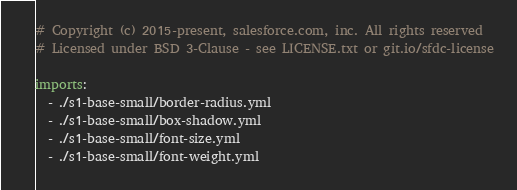<code> <loc_0><loc_0><loc_500><loc_500><_YAML_># Copyright (c) 2015-present, salesforce.com, inc. All rights reserved
# Licensed under BSD 3-Clause - see LICENSE.txt or git.io/sfdc-license

imports:
  - ./s1-base-small/border-radius.yml
  - ./s1-base-small/box-shadow.yml
  - ./s1-base-small/font-size.yml
  - ./s1-base-small/font-weight.yml
</code> 